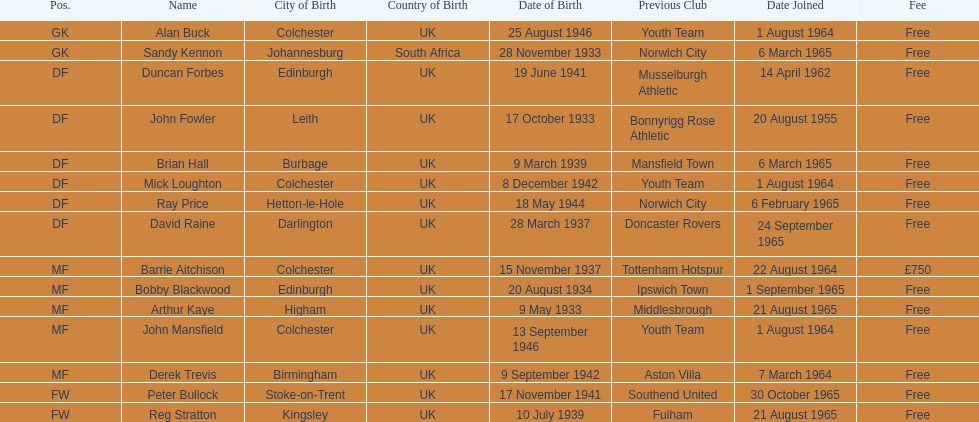Which player is the oldest? Arthur Kaye. 